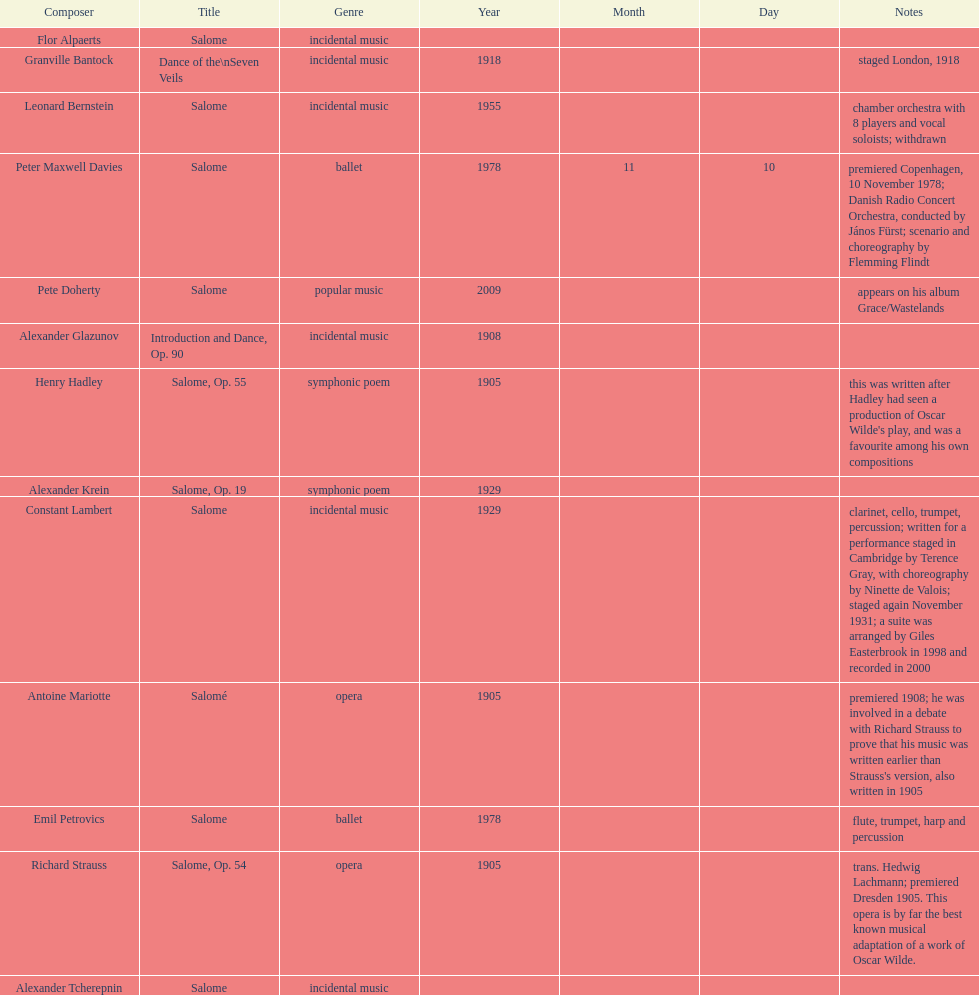What is the number of works titled "salome?" 11. 